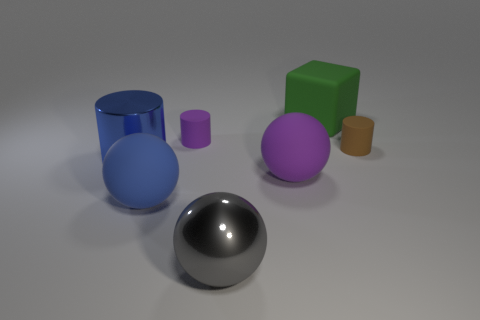There is a metal thing that is the same shape as the blue rubber thing; what is its color?
Provide a short and direct response. Gray. What is the size of the brown thing that is the same shape as the small purple rubber object?
Make the answer very short. Small. The thing that is both behind the tiny brown matte cylinder and to the right of the purple rubber cylinder is made of what material?
Make the answer very short. Rubber. Do the large matte sphere that is to the left of the large gray metal ball and the big metal cylinder have the same color?
Offer a terse response. Yes. Is the color of the large cube the same as the large metal thing that is on the right side of the large blue shiny cylinder?
Offer a terse response. No. Are there any big things behind the large purple rubber ball?
Provide a short and direct response. Yes. Do the large green thing and the purple cylinder have the same material?
Ensure brevity in your answer.  Yes. There is a purple ball that is the same size as the blue rubber ball; what is its material?
Provide a short and direct response. Rubber. What number of things are objects on the left side of the big purple object or green shiny blocks?
Offer a very short reply. 4. Are there the same number of purple cylinders to the right of the green cube and green balls?
Provide a succinct answer. Yes. 